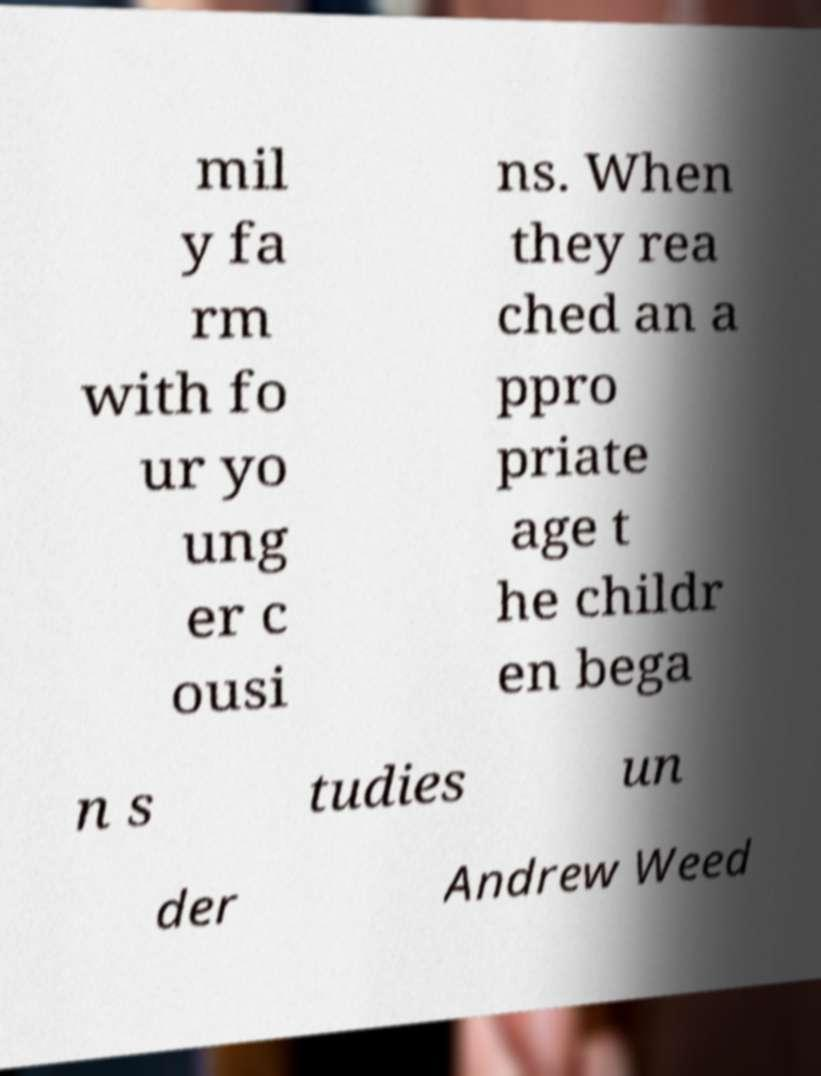There's text embedded in this image that I need extracted. Can you transcribe it verbatim? mil y fa rm with fo ur yo ung er c ousi ns. When they rea ched an a ppro priate age t he childr en bega n s tudies un der Andrew Weed 